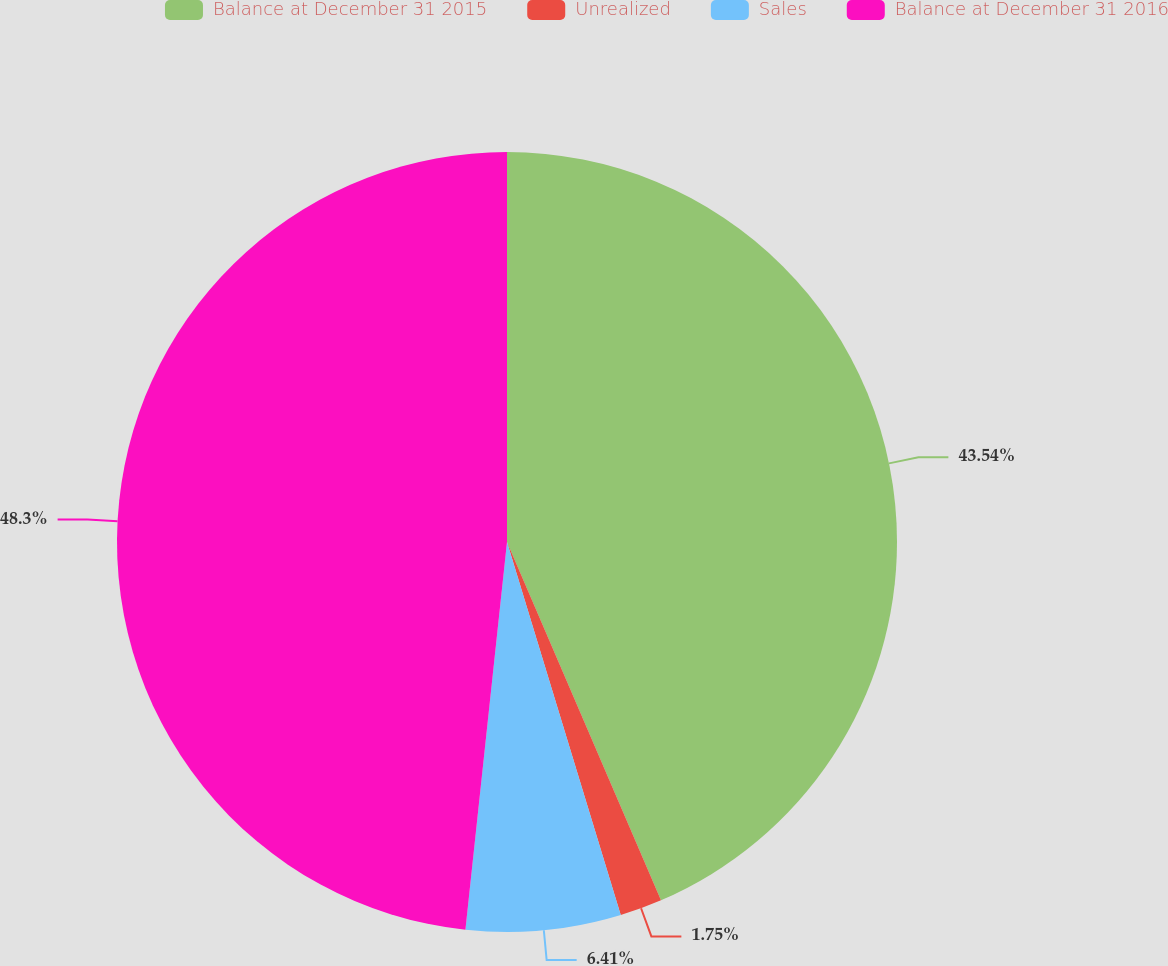Convert chart to OTSL. <chart><loc_0><loc_0><loc_500><loc_500><pie_chart><fcel>Balance at December 31 2015<fcel>Unrealized<fcel>Sales<fcel>Balance at December 31 2016<nl><fcel>43.54%<fcel>1.75%<fcel>6.41%<fcel>48.3%<nl></chart> 